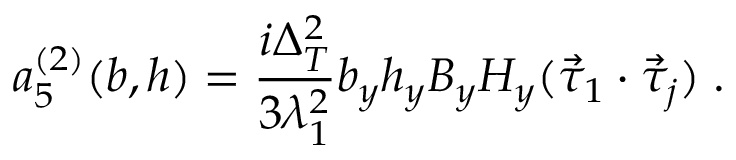Convert formula to latex. <formula><loc_0><loc_0><loc_500><loc_500>a _ { 5 } ^ { ( 2 ) } ( b , h ) = \frac { i \Delta _ { T } ^ { 2 } } { 3 \lambda _ { 1 } ^ { 2 } } b _ { y } h _ { y } B _ { y } H _ { y } ( \vec { \tau } _ { 1 } \cdot \vec { \tau } _ { j } ) \, .</formula> 